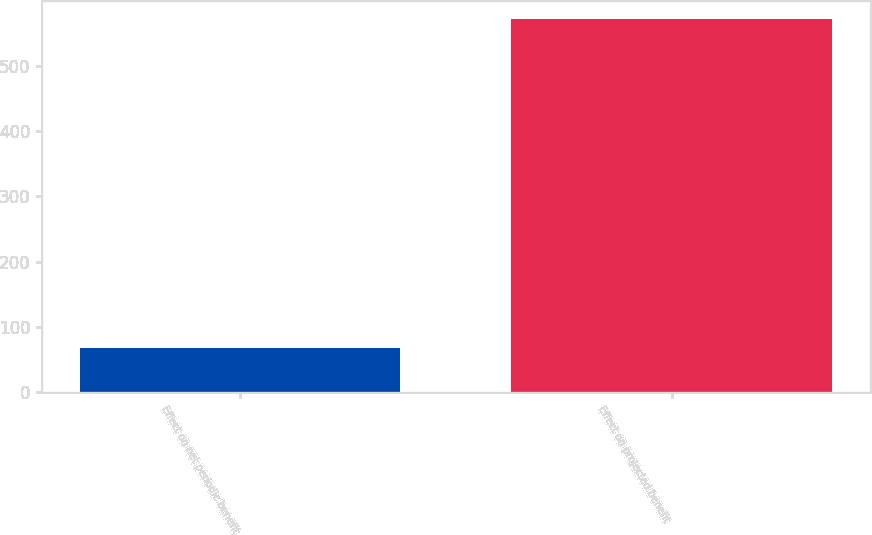Convert chart to OTSL. <chart><loc_0><loc_0><loc_500><loc_500><bar_chart><fcel>Effect on net periodic benefit<fcel>Effect on projected benefit<nl><fcel>67<fcel>571<nl></chart> 